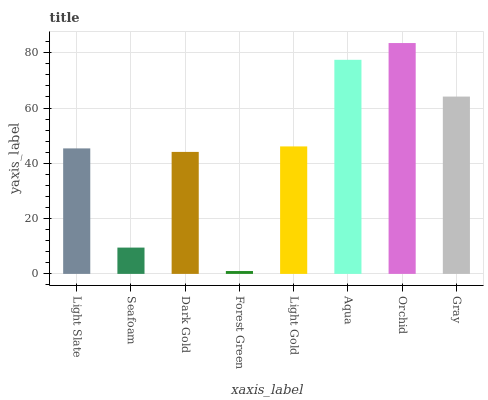Is Forest Green the minimum?
Answer yes or no. Yes. Is Orchid the maximum?
Answer yes or no. Yes. Is Seafoam the minimum?
Answer yes or no. No. Is Seafoam the maximum?
Answer yes or no. No. Is Light Slate greater than Seafoam?
Answer yes or no. Yes. Is Seafoam less than Light Slate?
Answer yes or no. Yes. Is Seafoam greater than Light Slate?
Answer yes or no. No. Is Light Slate less than Seafoam?
Answer yes or no. No. Is Light Gold the high median?
Answer yes or no. Yes. Is Light Slate the low median?
Answer yes or no. Yes. Is Seafoam the high median?
Answer yes or no. No. Is Gray the low median?
Answer yes or no. No. 